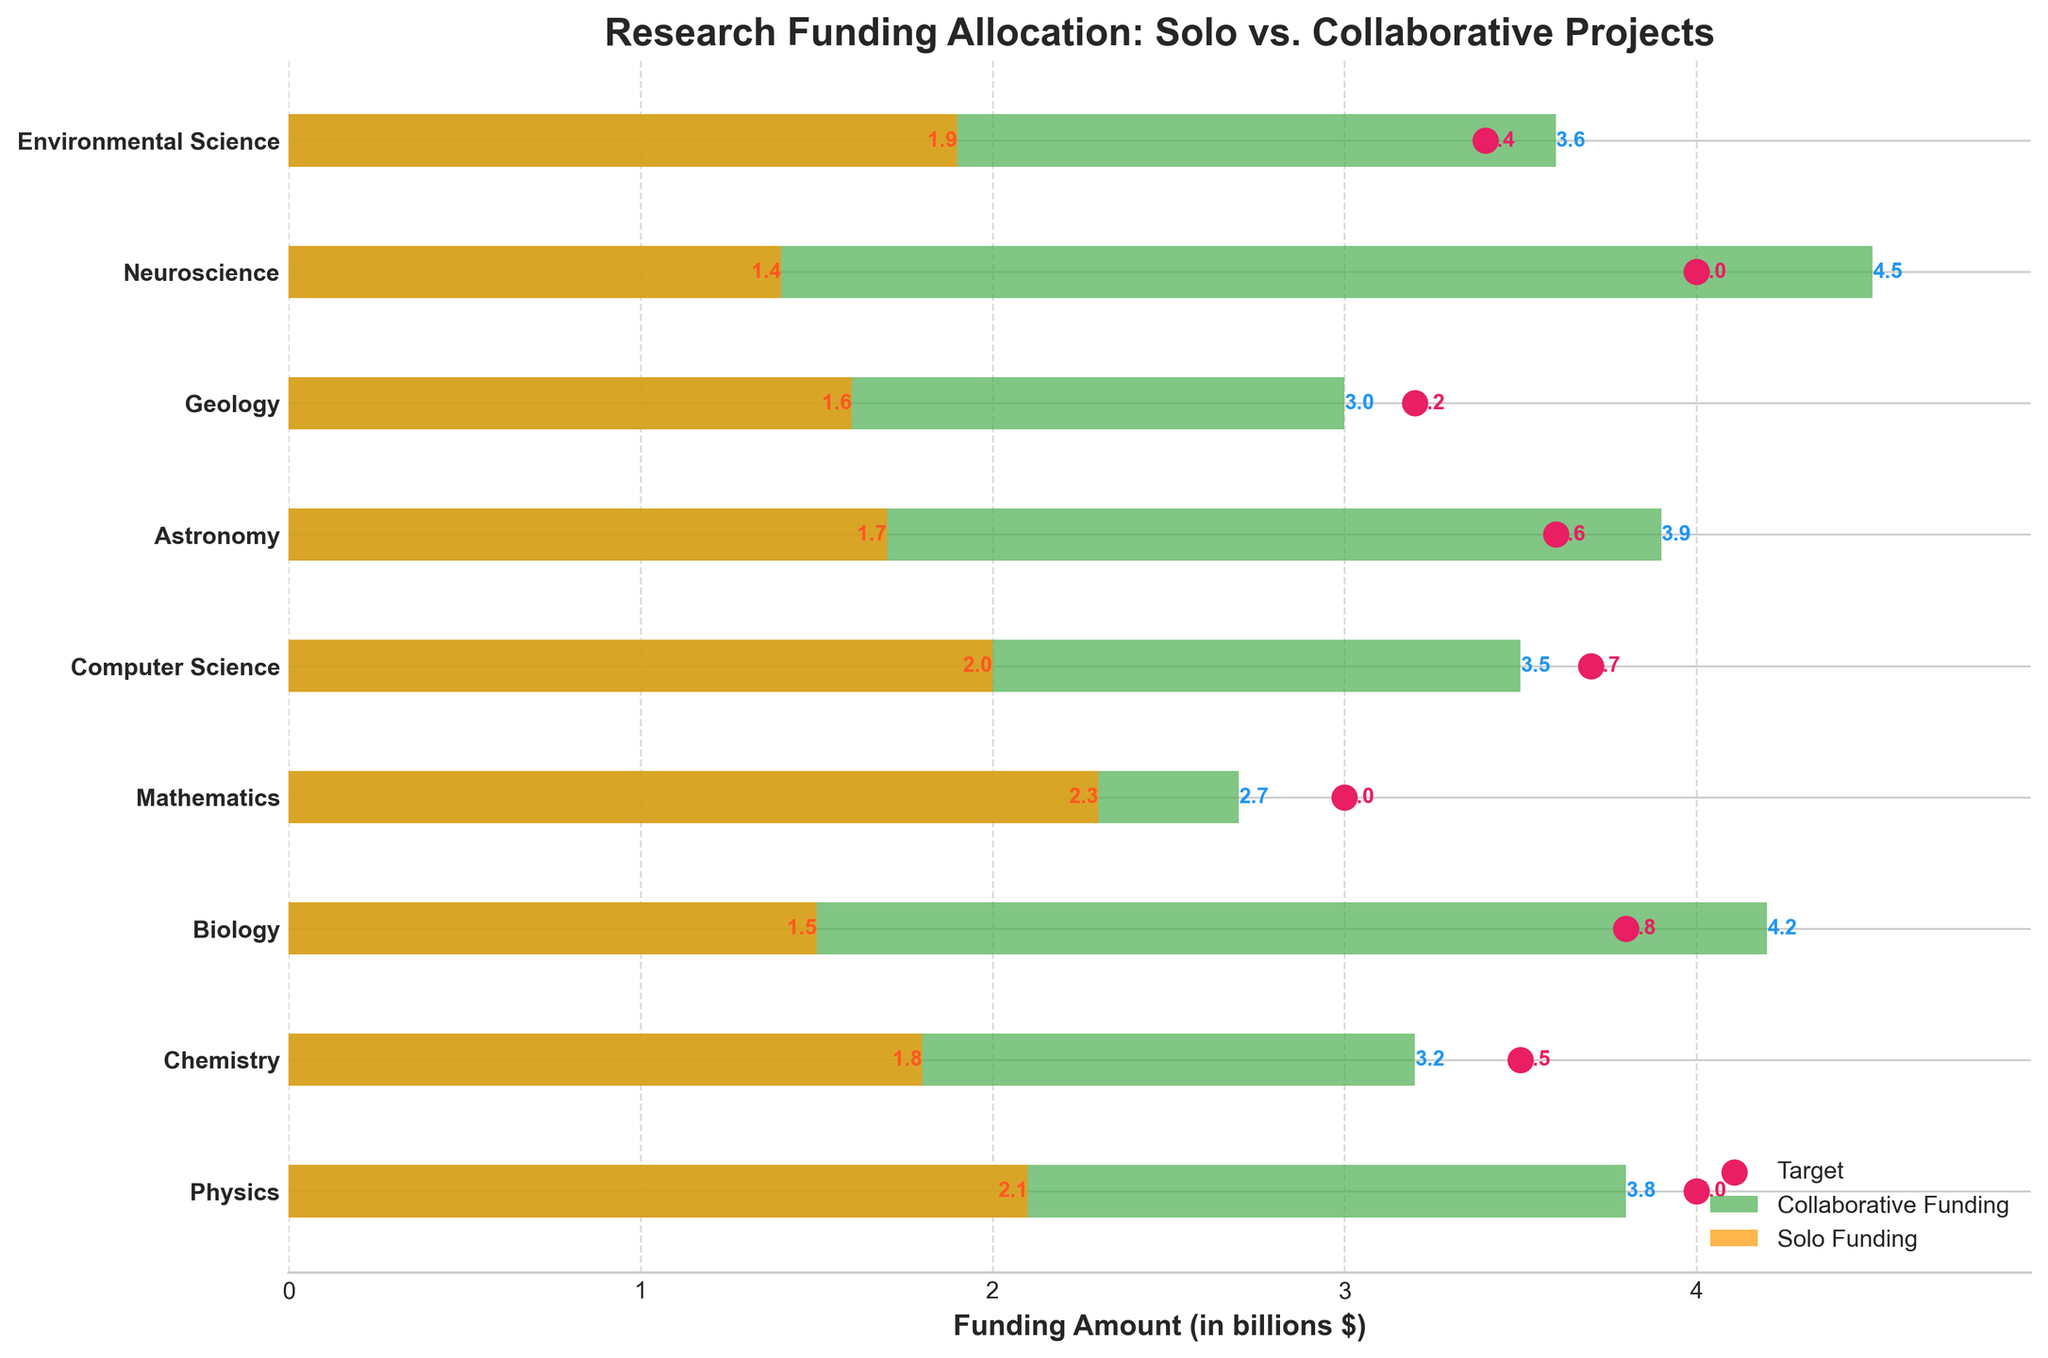What is the title of the plot? The plot's title is prominently displayed at the top in bold. It reads 'Research Funding Allocation: Solo vs. Collaborative Projects'
Answer: Research Funding Allocation: Solo vs. Collaborative Projects Which discipline received the highest amount of collaborative funding? Look at the green bars representing collaborative funding. The tallest green bar corresponds to Neuroscience with a value of 4.5 billion dollars.
Answer: Neuroscience What target funding is set for Mathematics? The target funding for Mathematics is shown as a red dot on the horizontal axis corresponding to Mathematics. The value next to the red dot states the target is 3.0 billion dollars.
Answer: 3.0 billion dollars How does the solo funding for Biology compare to its target funding? Examine the orange bar (solo funding) and the red dot (target funding) for Biology. The solo funding is 1.5 billion dollars, whereas the target is 3.8 billion dollars, showing solo funding is 2.3 billion dollars below the target.
Answer: 2.3 billion dollars below the target Which discipline has the smallest difference between its solo and collaborative funding? Look at the differences between the orange and green bars for each discipline. Environmental Science has the smallest difference, with 1.9 billion dollars in solo funding and 3.6 billion dollars in collaborative funding, a difference of 1.7 billion dollars.
Answer: Environmental Science How many disciplines have their collaborative funding meeting or exceeding the target? Compare the green bars to the red dots for each discipline. Biomedical sciences (Neuroscience) meet or exceed the target (3.8).
Answer: One discipline Is the solo funding for Computer Science greater than the collaborative funding for Geology? Compare the orange bar for Computer Science with the green bar for Geology. Computer Science's solo funding is 2.0 billion dollars, while Geology's collaborative funding is 3.0 billion dollars. The solo funding for Computer Science is not greater.
Answer: No What is the total amount of solo funding across all disciplines? Sum the values of all the orange bars (solo funding): 2.1 + 1.8 + 1.5 + 2.3 + 2.0 + 1.7 + 1.6 + 1.4 + 1.9 = 16.3 billion dollars.
Answer: 16.3 billion dollars Which discipline has the highest target funding and what's its value? Look at the red dots and find the highest one. Neuroscience with a target funding of 4.0 billion dollars.
Answer: Neuroscience with 4.0 billion dollars What is the average collaborative funding across all disciplines? Sum the values of all the green bars (collaborative funding) and divide by the number of disciplines: (3.8 + 3.2 + 4.2 + 2.7 + 3.5 + 3.9 + 3.0 + 4.5 + 3.6) / 9 = 32.4 / 9 = 3.6 billion dollars
Answer: 3.6 billion dollars 